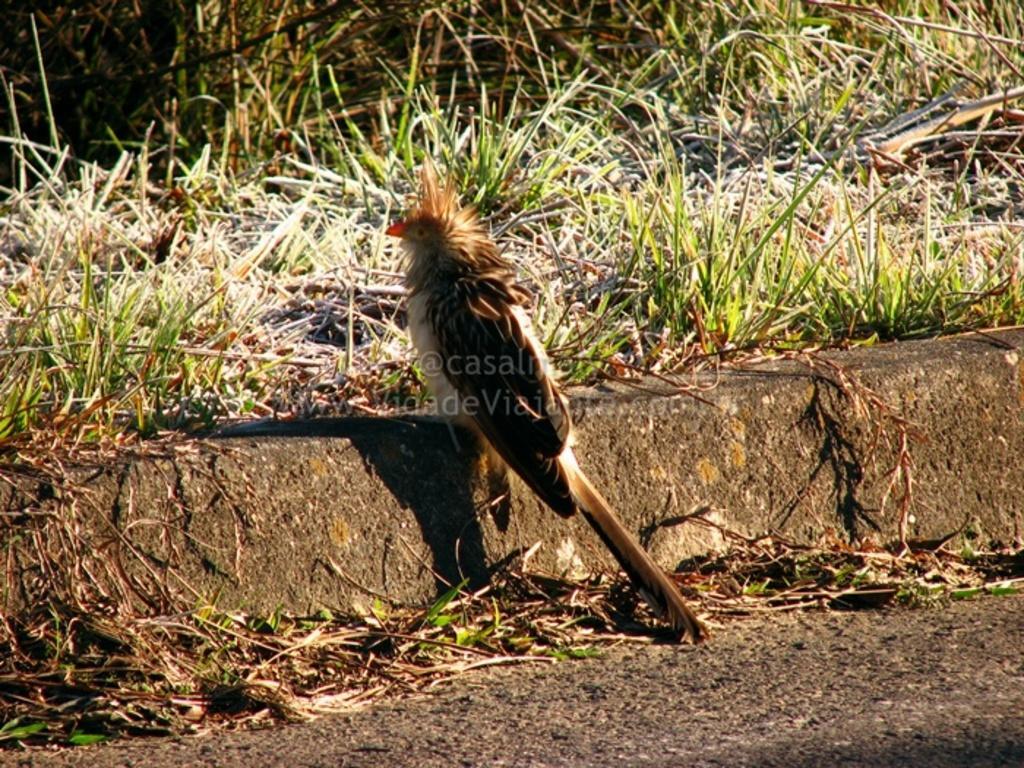Could you give a brief overview of what you see in this image? In this picture we can see grass and a bird. In the middle portion of the picture we can see watermark. 